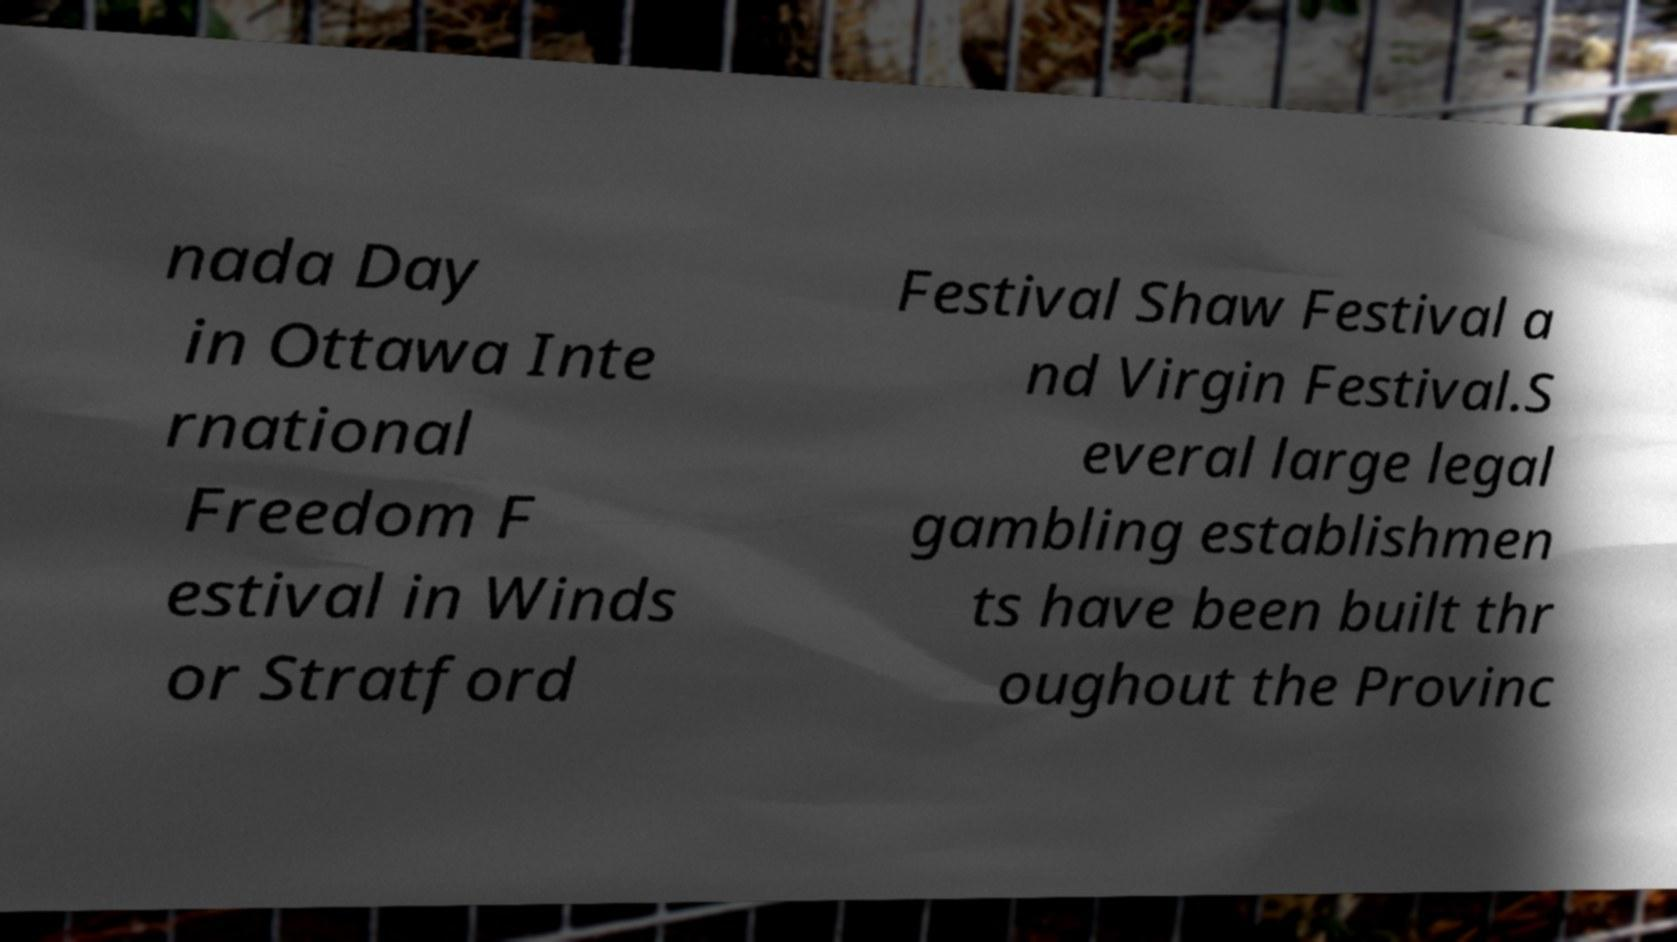Please read and relay the text visible in this image. What does it say? nada Day in Ottawa Inte rnational Freedom F estival in Winds or Stratford Festival Shaw Festival a nd Virgin Festival.S everal large legal gambling establishmen ts have been built thr oughout the Provinc 